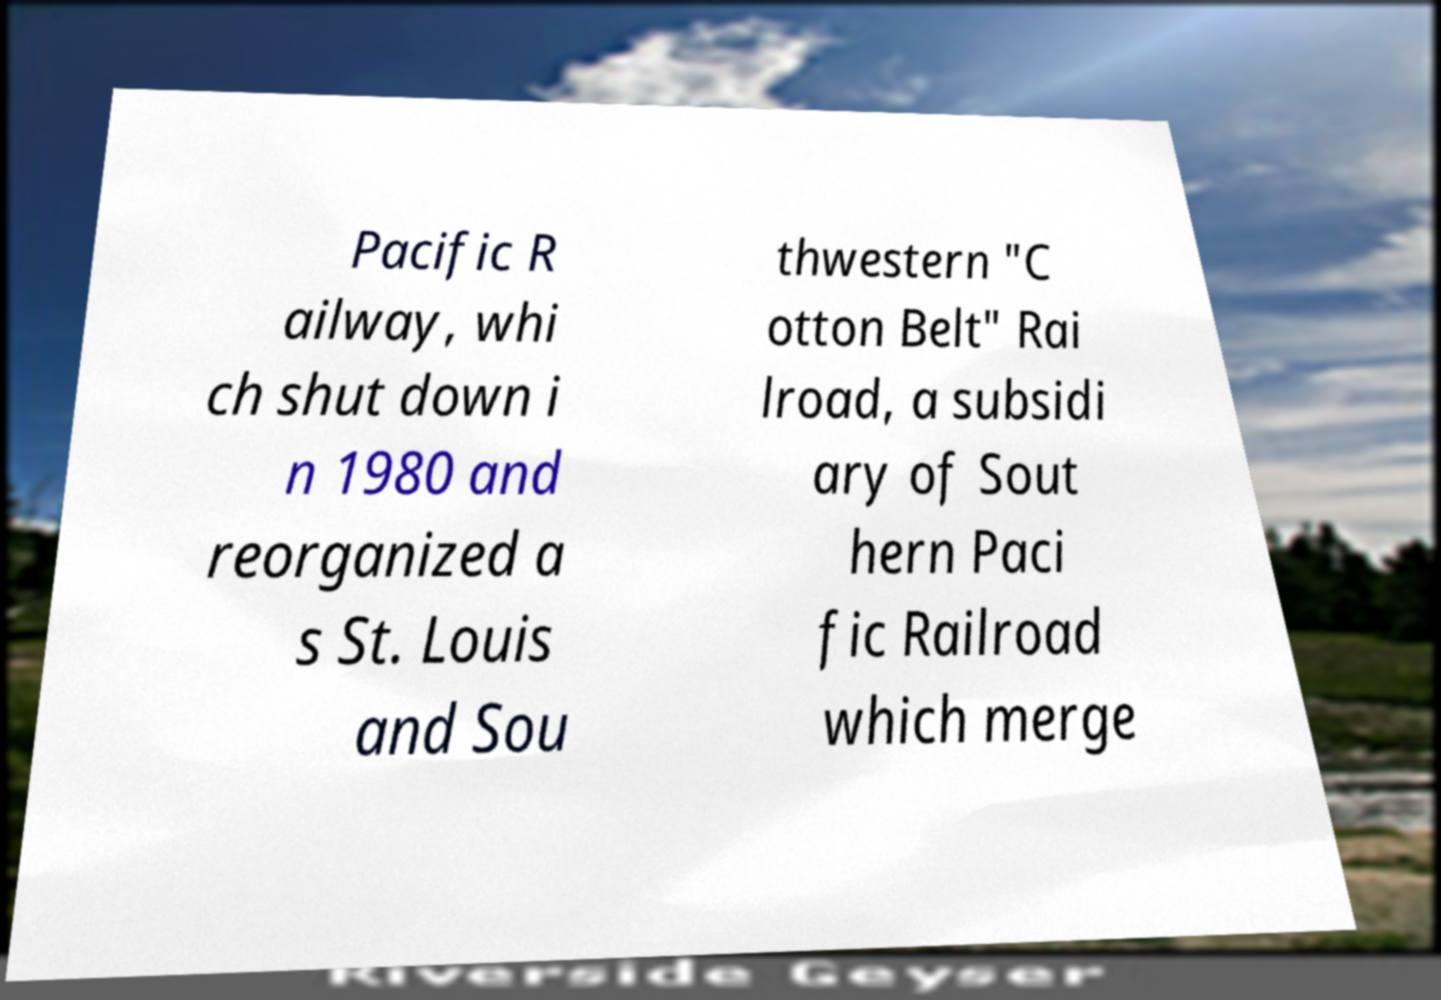For documentation purposes, I need the text within this image transcribed. Could you provide that? Pacific R ailway, whi ch shut down i n 1980 and reorganized a s St. Louis and Sou thwestern "C otton Belt" Rai lroad, a subsidi ary of Sout hern Paci fic Railroad which merge 